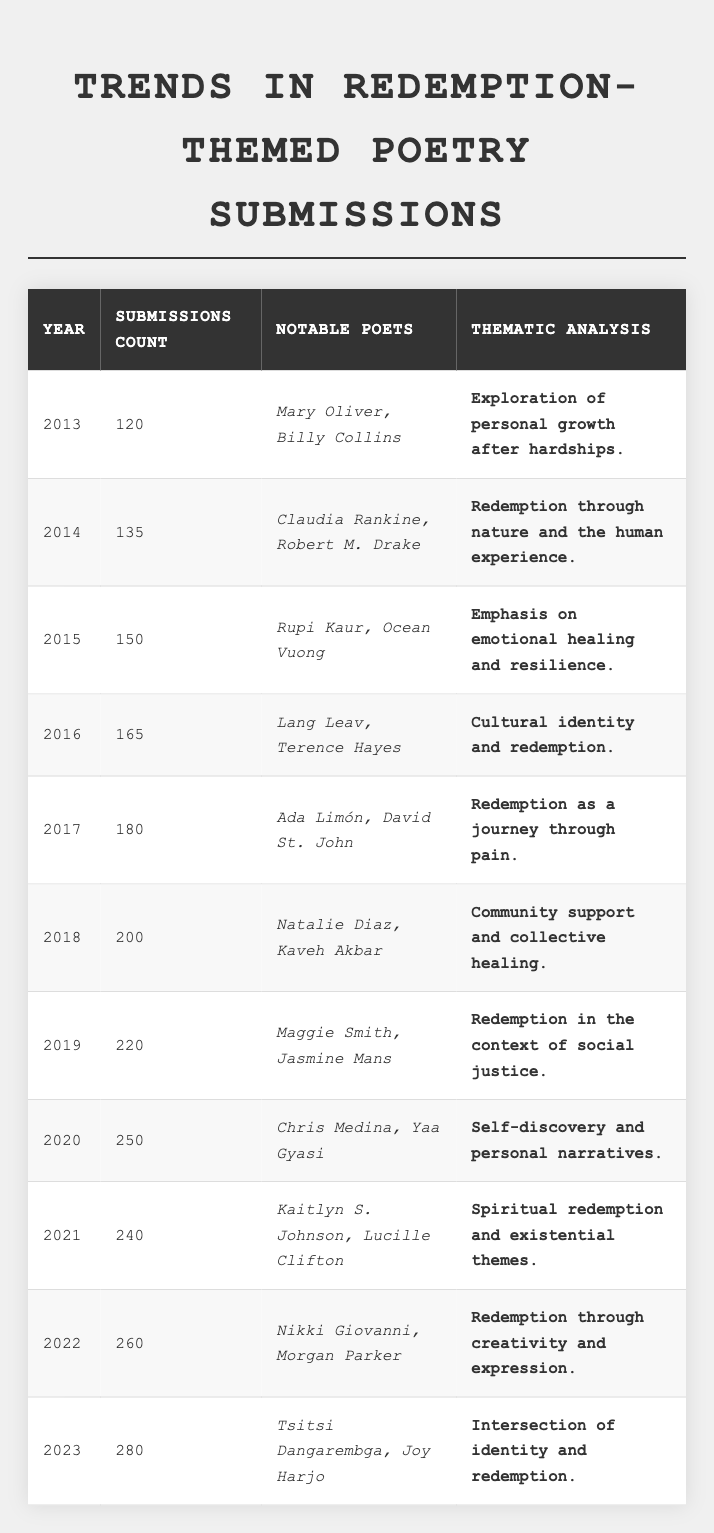What was the highest number of poetry submissions in a single year? The highest number of submissions in the table is found in the year 2023, where the count is 280.
Answer: 280 Which year had the fewest submissions? The year with the fewest submissions is 2013, which had 120 submissions.
Answer: 120 How much did poetry submissions increase from 2019 to 2020? In 2019, there were 220 submissions, and in 2020, there were 250 submissions. The difference is 250 - 220 = 30.
Answer: 30 Who were the notable poets in 2016? The notable poets in 2016 were Lang Leav and Terence Hayes.
Answer: Lang Leav and Terence Hayes What was the thematic analysis for the year 2022? The thematic analysis for 2022 described redemption through creativity and expression.
Answer: Redemption through creativity and expression Between which years did the submissions see the largest increase? To find the largest increase, we compare the differences between each consecutive year's submissions. The largest increase is from 2022 (260) to 2023 (280), which is 20.
Answer: 20 Was there a decline in submissions from 2020 to 2021? No, there was no decline; submissions decreased from 250 in 2020 to 240 in 2021.
Answer: Yes What was the thematic focus in poetry submissions from 2017? In 2017, the thematic focus was on redemption as a journey through pain.
Answer: Redemption as a journey through pain How many notable poets were mentioned in the submissions for 2019? In 2019, the notable poets mentioned were Maggie Smith and Jasmine Mans, which totals two poets.
Answer: 2 What was the average number of submissions from 2015 to 2020? The submissions from 2015 to 2020 are 150, 165, 180, 200, 220, and 250. Their sum is 150 + 165 + 180 + 200 + 220 + 250 = 1165; dividing by 6 gives an average of 1165/6 = 194.17 (approximately 194).
Answer: 194.17 